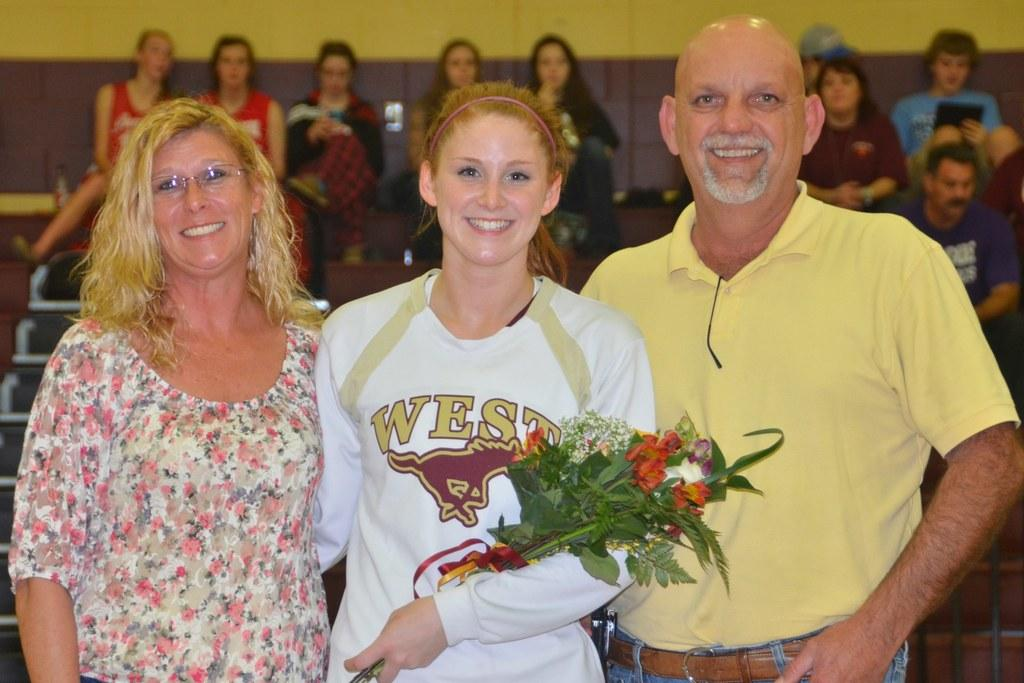How many people are standing and smiling in the image? There are three persons standing and smiling in the image. Who is holding a bouquet in the image? There is a person holding a bouquet in the image. What can be seen in the background of the image? There is a group of people sitting on chairs and a wall visible in the background of the image. Where is the lunchroom located in the image? There is no mention of a lunchroom in the image; it features three persons standing and smiling, a person holding a bouquet, and a group of people sitting on chairs in the background. 